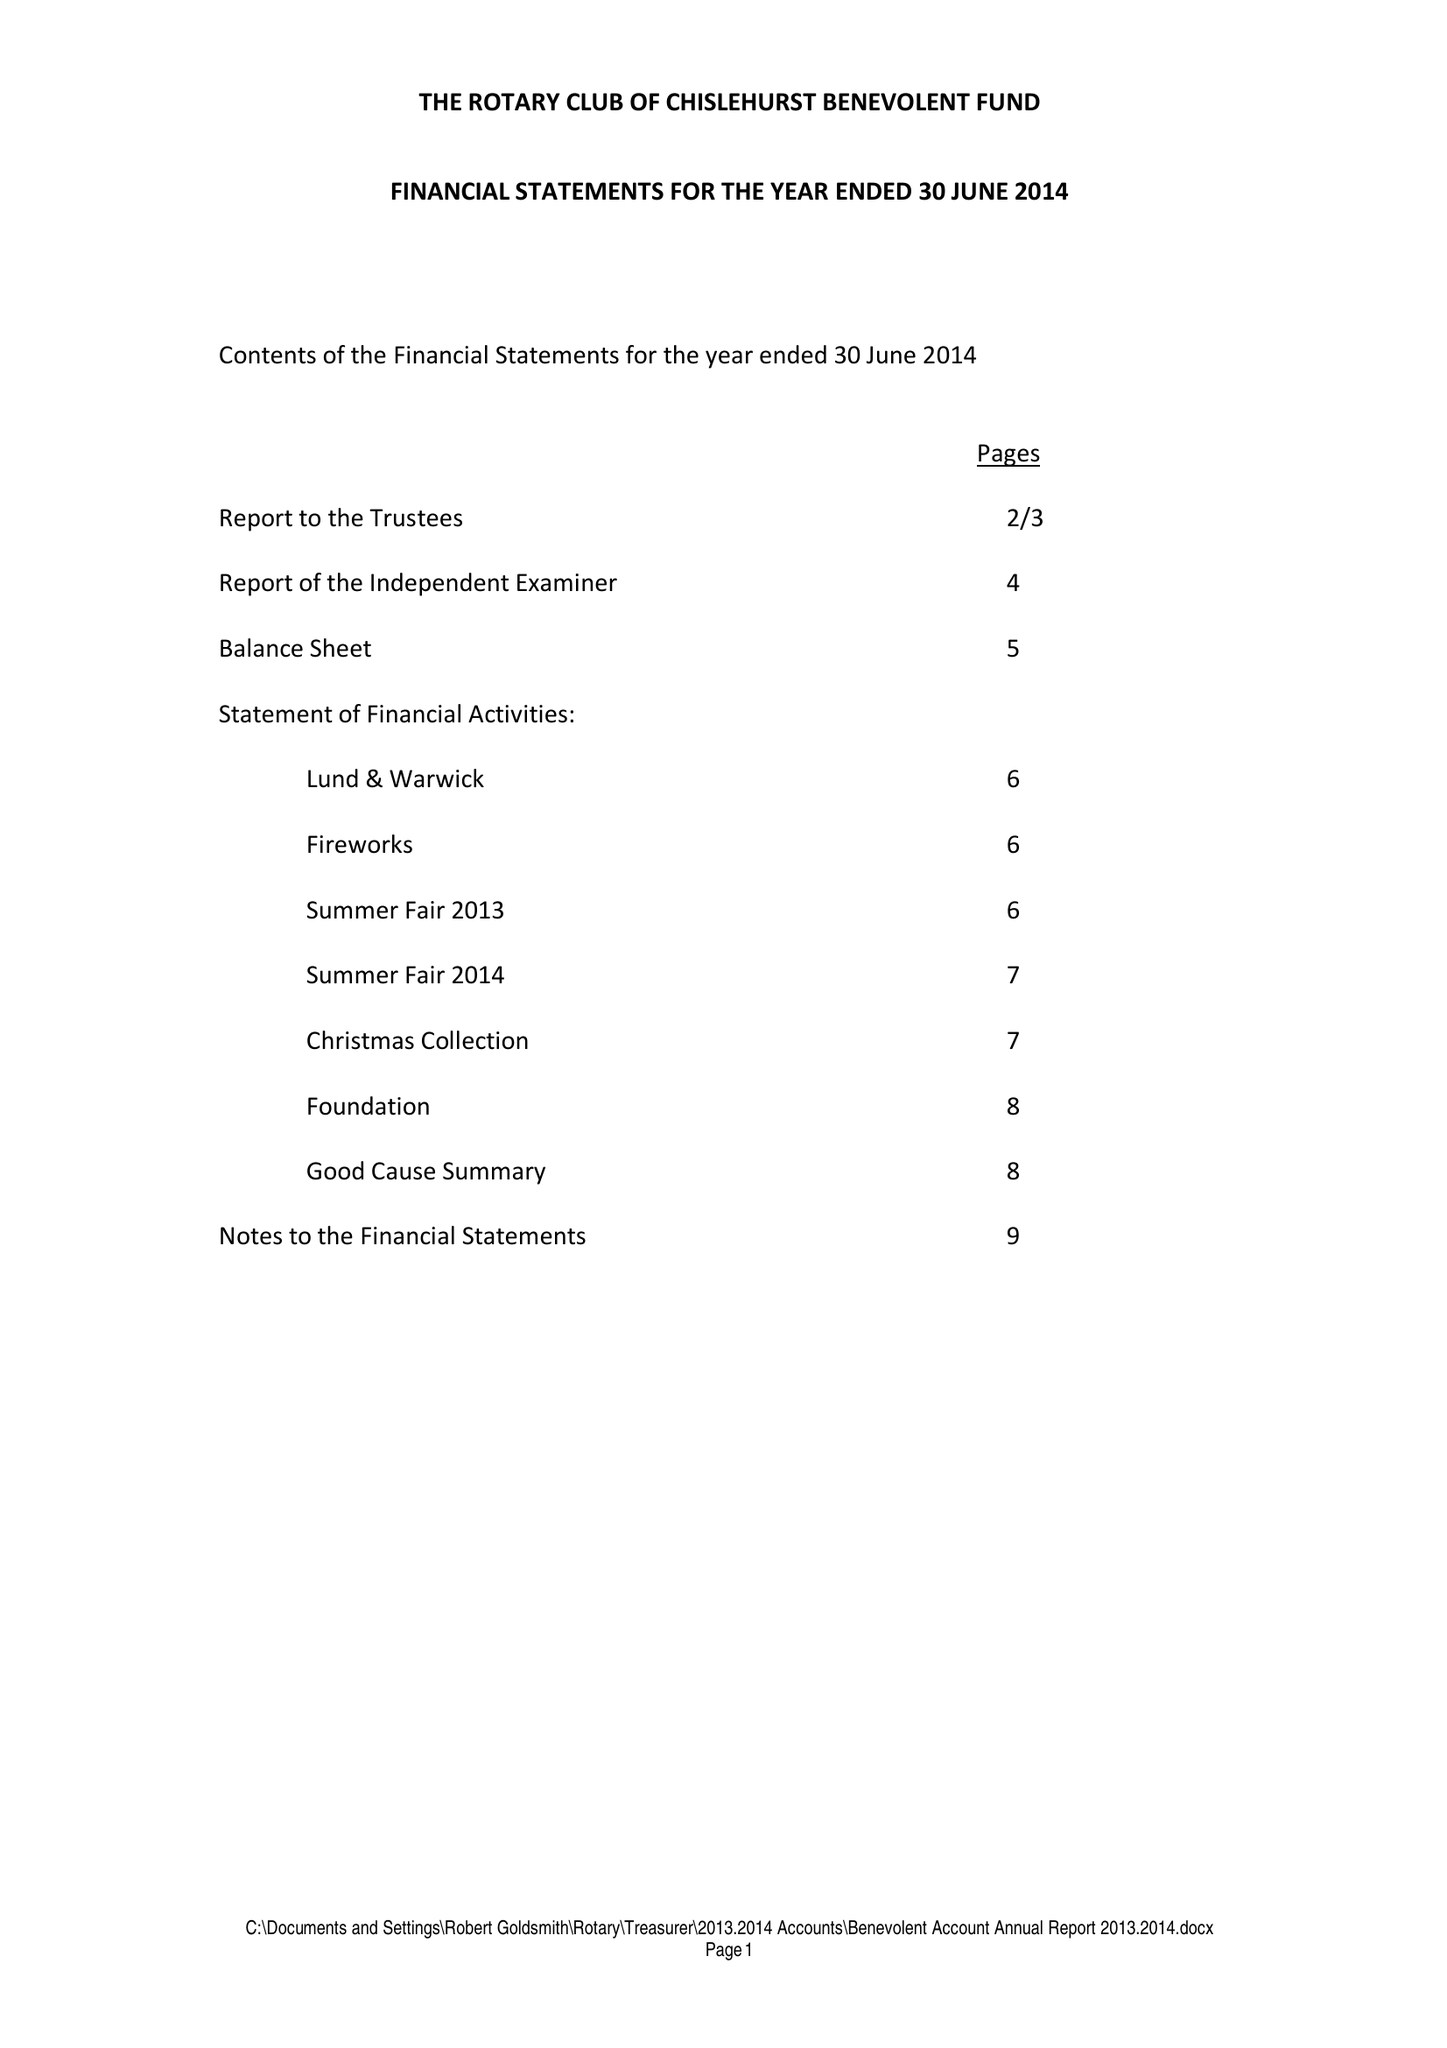What is the value for the charity_number?
Answer the question using a single word or phrase. 257747 